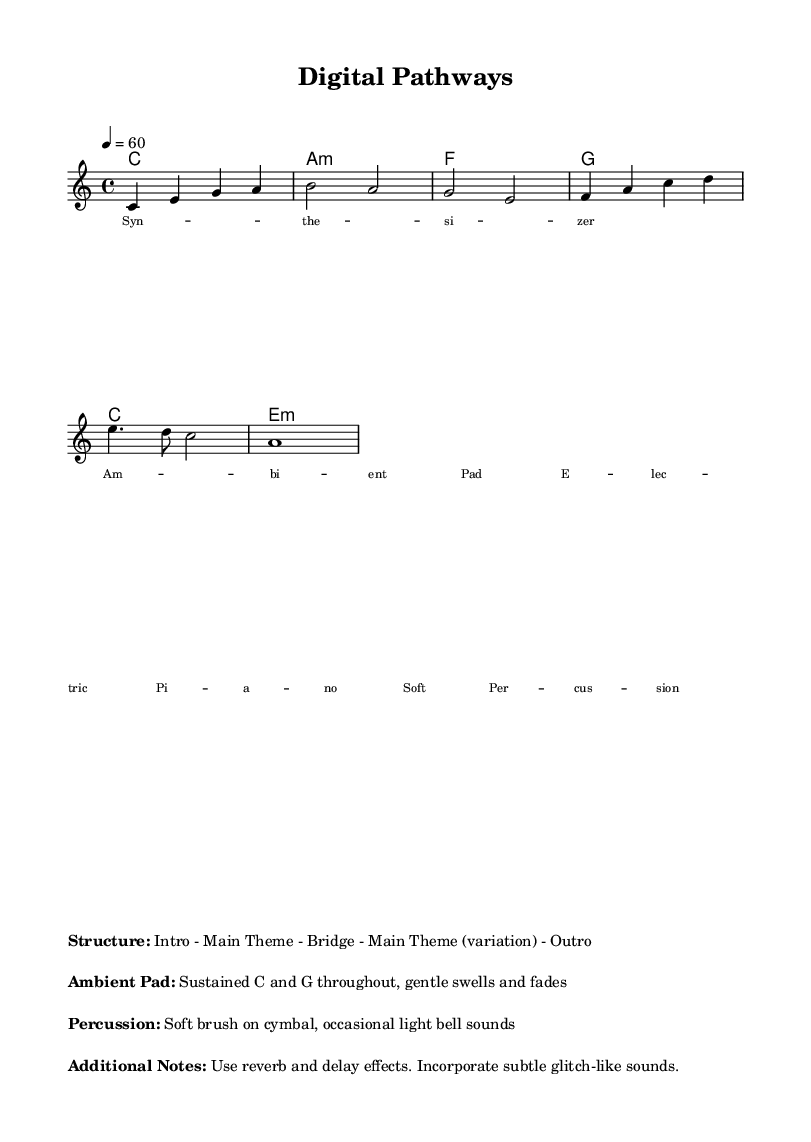What is the key signature of this music? The key signature displayed in the score is C major, which is indicated at the beginning of the global section and has no sharps or flats.
Answer: C major What is the time signature of this piece? The time signature shows a 4/4 notation at the beginning of the score, indicating four beats per measure.
Answer: 4/4 What is the tempo marking for this piece? The tempo marking shown in the score indicates that the piece should be played at a speed of 60 beats per minute.
Answer: 60 How many measures are in the melody? To determine the number of measures, we can count the individual measures described in the melody section, which totals seven measures.
Answer: 7 What is the first chord in the harmony section? The first chord listed in the harmony section is a C major chord. This is often represented by the note C as the root of the chord.
Answer: C What kind of percussion is suggested in the additional notes? The additional notes indicate that the percussion should consist of a soft brush on cymbals, creating a gentle sound to blend with the ambient nature of the piece.
Answer: Soft brush on cymbal What type of ambient instrument is mentioned in the lyrics? The lyrics mention an "Ambient Pad," which refers to a synthesized sound typically used in ambient music to create a lush and sustaining background.
Answer: Ambient Pad 